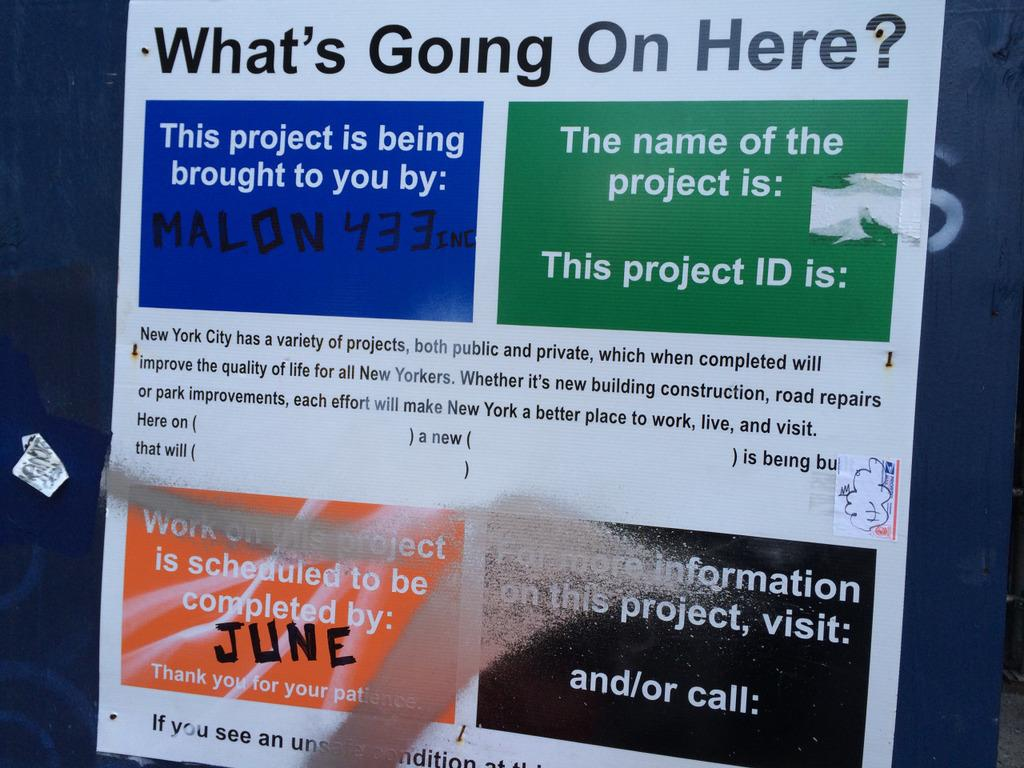<image>
Write a terse but informative summary of the picture. Sign that says "What's Going on Here?" on a blue wall. 